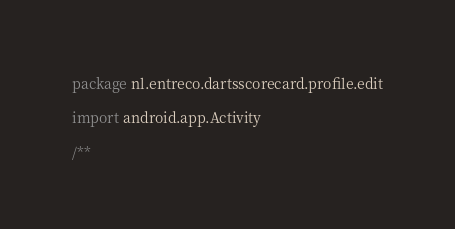Convert code to text. <code><loc_0><loc_0><loc_500><loc_500><_Kotlin_>package nl.entreco.dartsscorecard.profile.edit

import android.app.Activity

/**</code> 